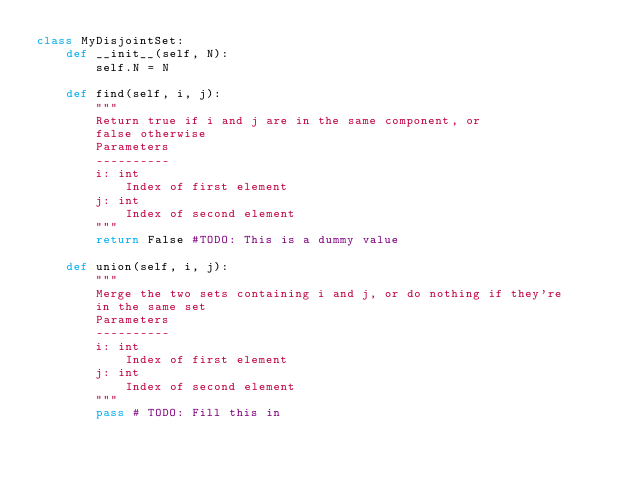Convert code to text. <code><loc_0><loc_0><loc_500><loc_500><_Python_>class MyDisjointSet:
    def __init__(self, N):
        self.N = N
    
    def find(self, i, j):
        """
        Return true if i and j are in the same component, or
        false otherwise
        Parameters
        ----------
        i: int
            Index of first element
        j: int
            Index of second element
        """
        return False #TODO: This is a dummy value
    
    def union(self, i, j):
        """
        Merge the two sets containing i and j, or do nothing if they're
        in the same set
        Parameters
        ----------
        i: int
            Index of first element
        j: int
            Index of second element
        """
        pass # TODO: Fill this in</code> 